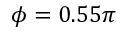Convert formula to latex. <formula><loc_0><loc_0><loc_500><loc_500>\phi = 0 . 5 5 \pi</formula> 